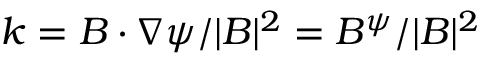<formula> <loc_0><loc_0><loc_500><loc_500>k = B \cdot \nabla \psi / | B | ^ { 2 } = B ^ { \psi } / | B | ^ { 2 }</formula> 